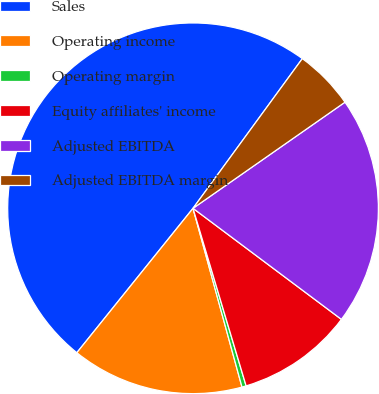Convert chart. <chart><loc_0><loc_0><loc_500><loc_500><pie_chart><fcel>Sales<fcel>Operating income<fcel>Operating margin<fcel>Equity affiliates' income<fcel>Adjusted EBITDA<fcel>Adjusted EBITDA margin<nl><fcel>49.26%<fcel>15.04%<fcel>0.37%<fcel>10.15%<fcel>19.93%<fcel>5.26%<nl></chart> 